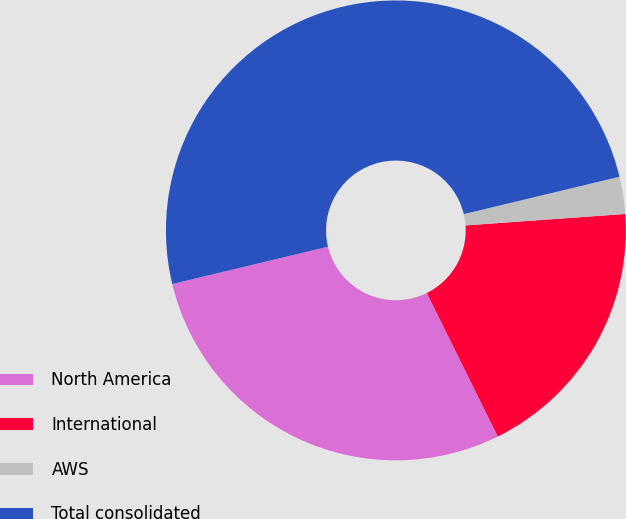Convert chart. <chart><loc_0><loc_0><loc_500><loc_500><pie_chart><fcel>North America<fcel>International<fcel>AWS<fcel>Total consolidated<nl><fcel>28.56%<fcel>18.83%<fcel>2.61%<fcel>50.0%<nl></chart> 